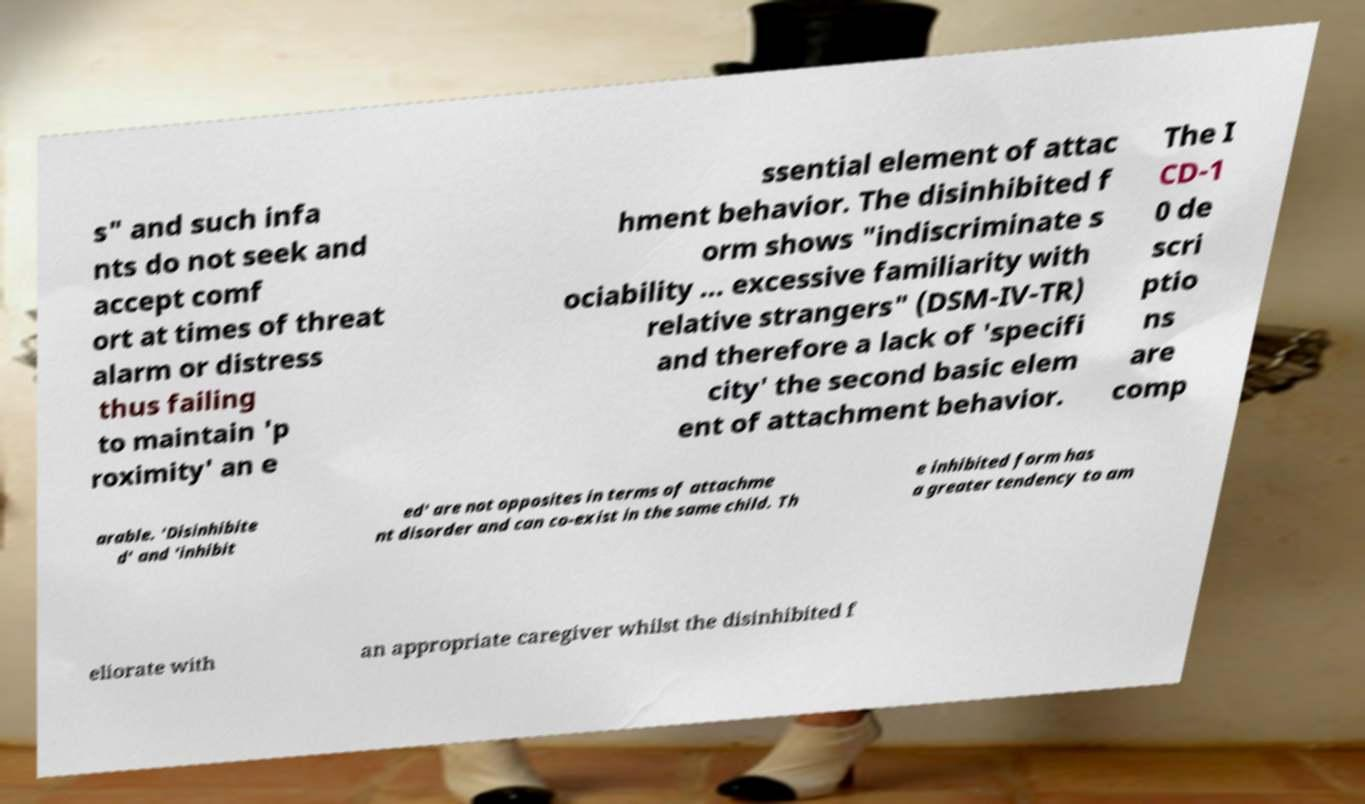I need the written content from this picture converted into text. Can you do that? s" and such infa nts do not seek and accept comf ort at times of threat alarm or distress thus failing to maintain 'p roximity' an e ssential element of attac hment behavior. The disinhibited f orm shows "indiscriminate s ociability ... excessive familiarity with relative strangers" (DSM-IV-TR) and therefore a lack of 'specifi city' the second basic elem ent of attachment behavior. The I CD-1 0 de scri ptio ns are comp arable. 'Disinhibite d' and 'inhibit ed' are not opposites in terms of attachme nt disorder and can co-exist in the same child. Th e inhibited form has a greater tendency to am eliorate with an appropriate caregiver whilst the disinhibited f 